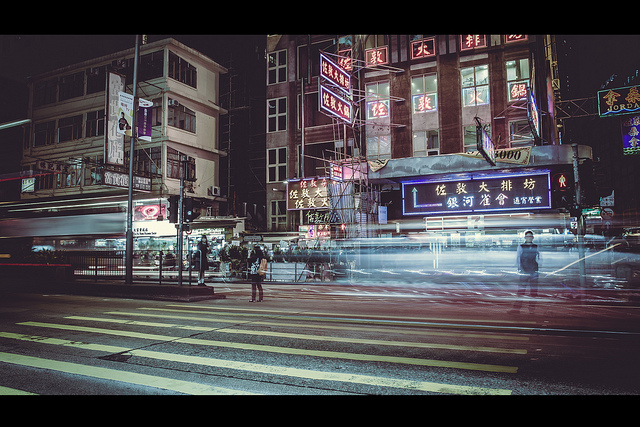<image>What does the neon sign say? I am not sure what the neon sign says. It appears to be in another language, possibly Chinese or Japanese. What team is on the billboard? It is unclear what team is on the billboard. It might be the 'lakers', 'knights', 'lions', or 'yankees', but I'm not sure. What food does the restaurant serve? It is ambiguous what food the restaurant serves. It could be Chinese food, hamburgers or Thai. What kind of information is on the blue sign? I am not sure what kind of information is on the blue sign. It can be the name of the business or type of business. What city was this picture taken? I don't know what city this picture was taken. It can be in Hong Kong, Beijing, New York or Tokyo. What does the neon sign say? I don't know what the neon sign says. It could be something in Japanese, Chinese, or another language. What team is on the billboard? I don't know what team is on the billboard. It is unknown. What food does the restaurant serve? I don't know what food the restaurant serves. It can be Chinese, hamburgers, or Thai. What kind of information is on the blue sign? I don't know what kind of information is on the blue sign. It could be the name of a Chinese business or the name of a store. What city was this picture taken? I am not sure what city this picture was taken. It can be seen that it is either Hong Kong, Beijing, New York, Tokyo, or China. 